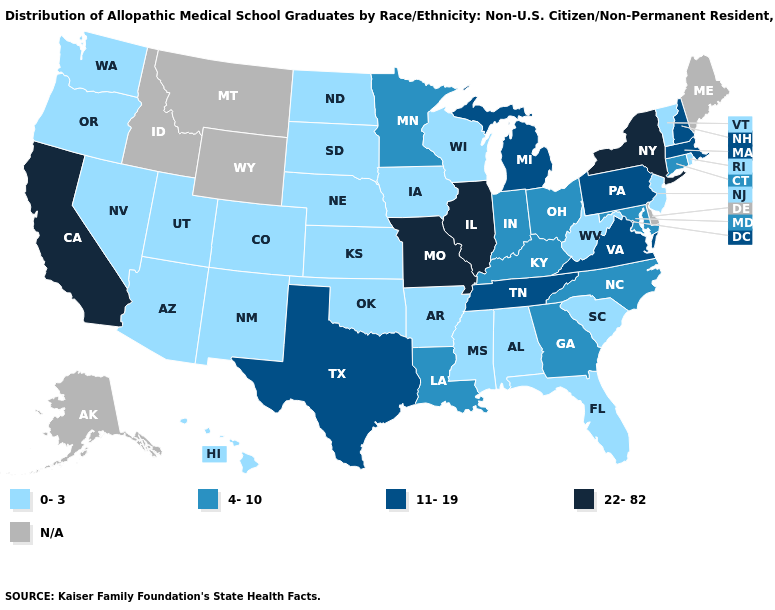Name the states that have a value in the range 22-82?
Short answer required. California, Illinois, Missouri, New York. Name the states that have a value in the range 4-10?
Write a very short answer. Connecticut, Georgia, Indiana, Kentucky, Louisiana, Maryland, Minnesota, North Carolina, Ohio. Name the states that have a value in the range N/A?
Be succinct. Alaska, Delaware, Idaho, Maine, Montana, Wyoming. Does California have the highest value in the West?
Answer briefly. Yes. Name the states that have a value in the range 11-19?
Short answer required. Massachusetts, Michigan, New Hampshire, Pennsylvania, Tennessee, Texas, Virginia. Does Alabama have the highest value in the South?
Answer briefly. No. Does the first symbol in the legend represent the smallest category?
Write a very short answer. Yes. Name the states that have a value in the range 4-10?
Short answer required. Connecticut, Georgia, Indiana, Kentucky, Louisiana, Maryland, Minnesota, North Carolina, Ohio. Which states have the lowest value in the USA?
Be succinct. Alabama, Arizona, Arkansas, Colorado, Florida, Hawaii, Iowa, Kansas, Mississippi, Nebraska, Nevada, New Jersey, New Mexico, North Dakota, Oklahoma, Oregon, Rhode Island, South Carolina, South Dakota, Utah, Vermont, Washington, West Virginia, Wisconsin. What is the value of Rhode Island?
Write a very short answer. 0-3. Name the states that have a value in the range 22-82?
Concise answer only. California, Illinois, Missouri, New York. Name the states that have a value in the range N/A?
Give a very brief answer. Alaska, Delaware, Idaho, Maine, Montana, Wyoming. What is the highest value in states that border Wisconsin?
Answer briefly. 22-82. Which states hav the highest value in the Northeast?
Quick response, please. New York. 